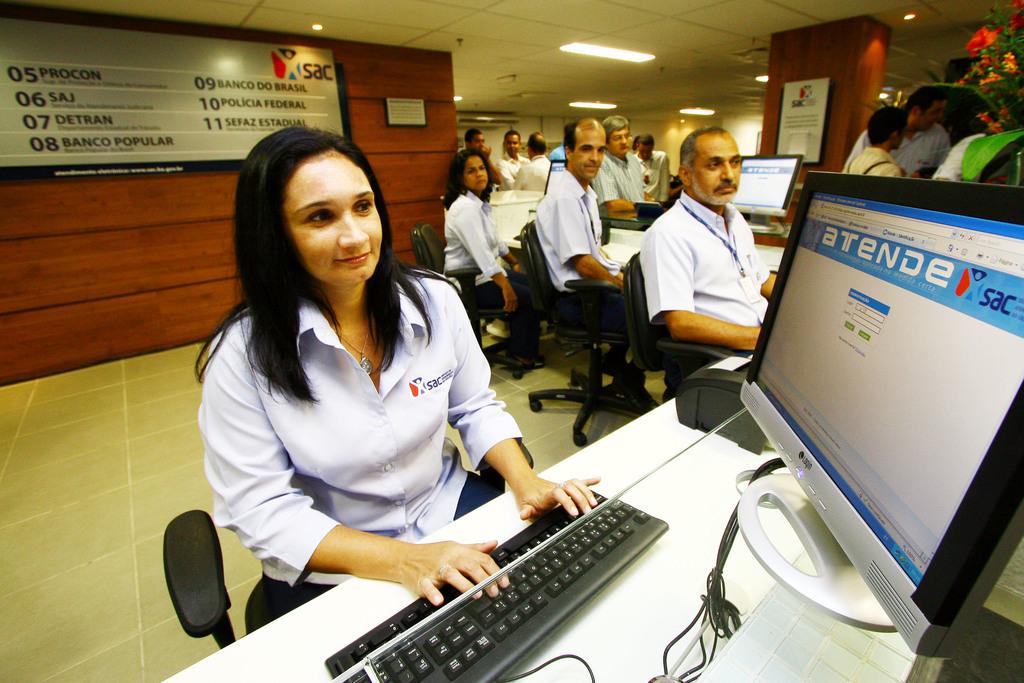What is the last number listed behind the woman?
Keep it short and to the point. 11. The last number on the list behind the girl is what?
Ensure brevity in your answer.  11. 